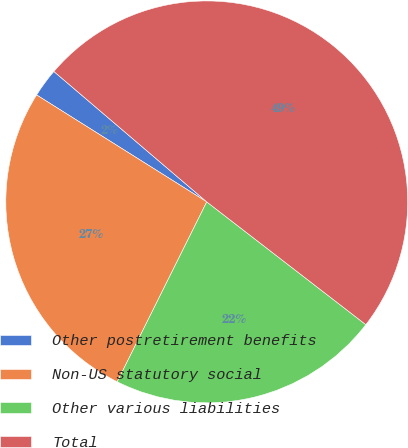Convert chart to OTSL. <chart><loc_0><loc_0><loc_500><loc_500><pie_chart><fcel>Other postretirement benefits<fcel>Non-US statutory social<fcel>Other various liabilities<fcel>Total<nl><fcel>2.31%<fcel>26.58%<fcel>21.89%<fcel>49.22%<nl></chart> 